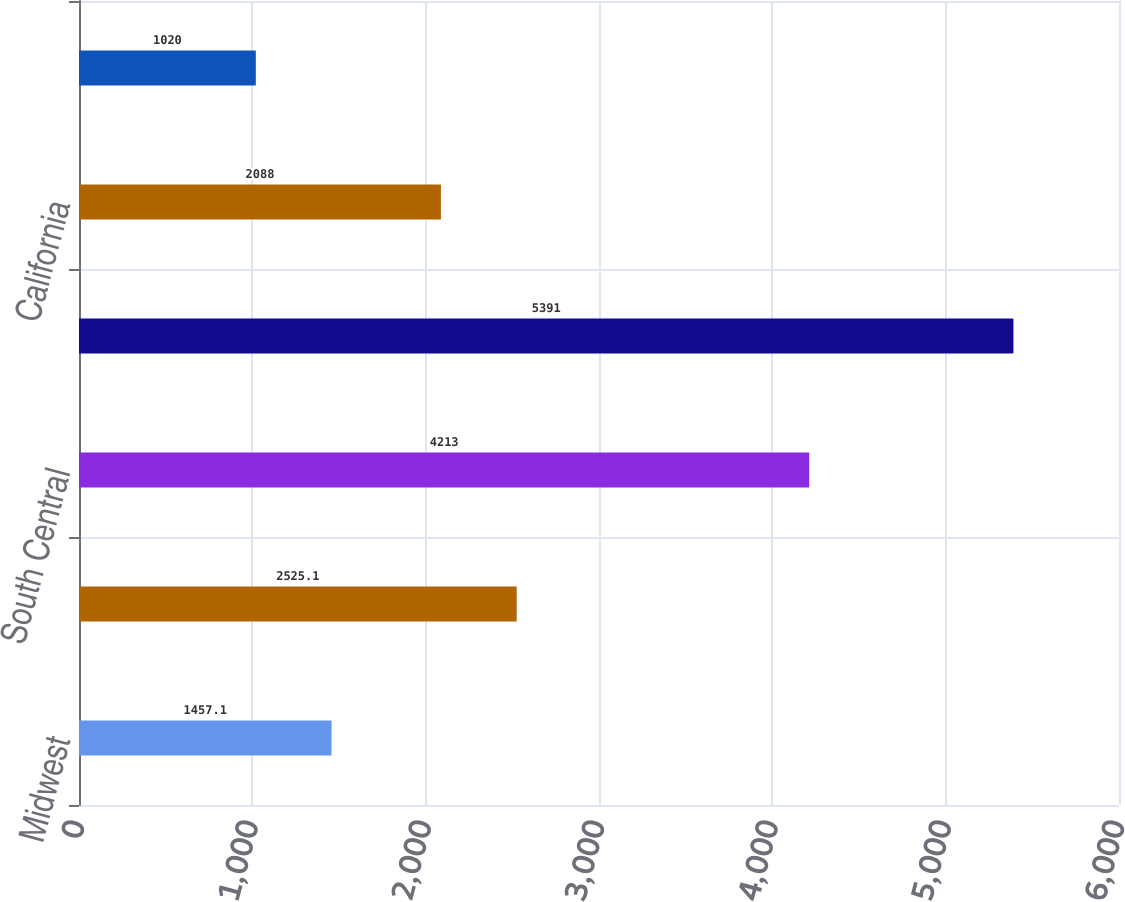Convert chart. <chart><loc_0><loc_0><loc_500><loc_500><bar_chart><fcel>Midwest<fcel>Southeast<fcel>South Central<fcel>Southwest<fcel>California<fcel>West<nl><fcel>1457.1<fcel>2525.1<fcel>4213<fcel>5391<fcel>2088<fcel>1020<nl></chart> 